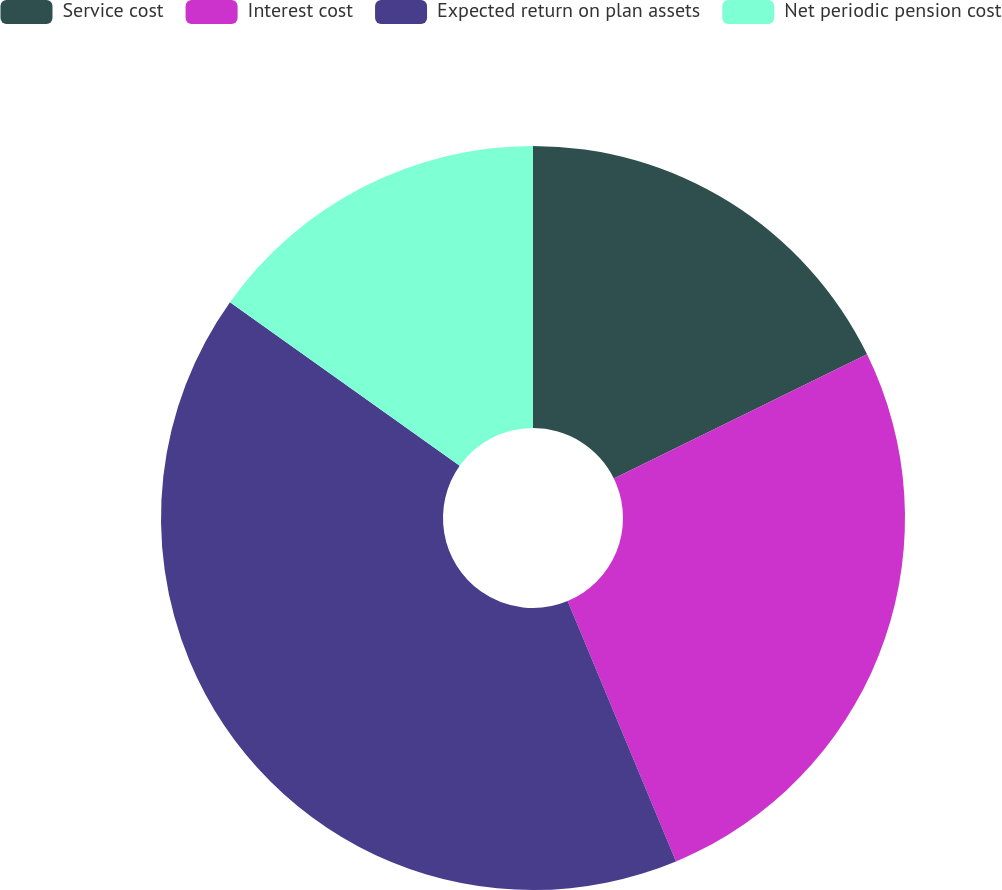Convert chart to OTSL. <chart><loc_0><loc_0><loc_500><loc_500><pie_chart><fcel>Service cost<fcel>Interest cost<fcel>Expected return on plan assets<fcel>Net periodic pension cost<nl><fcel>17.75%<fcel>25.97%<fcel>41.13%<fcel>15.15%<nl></chart> 